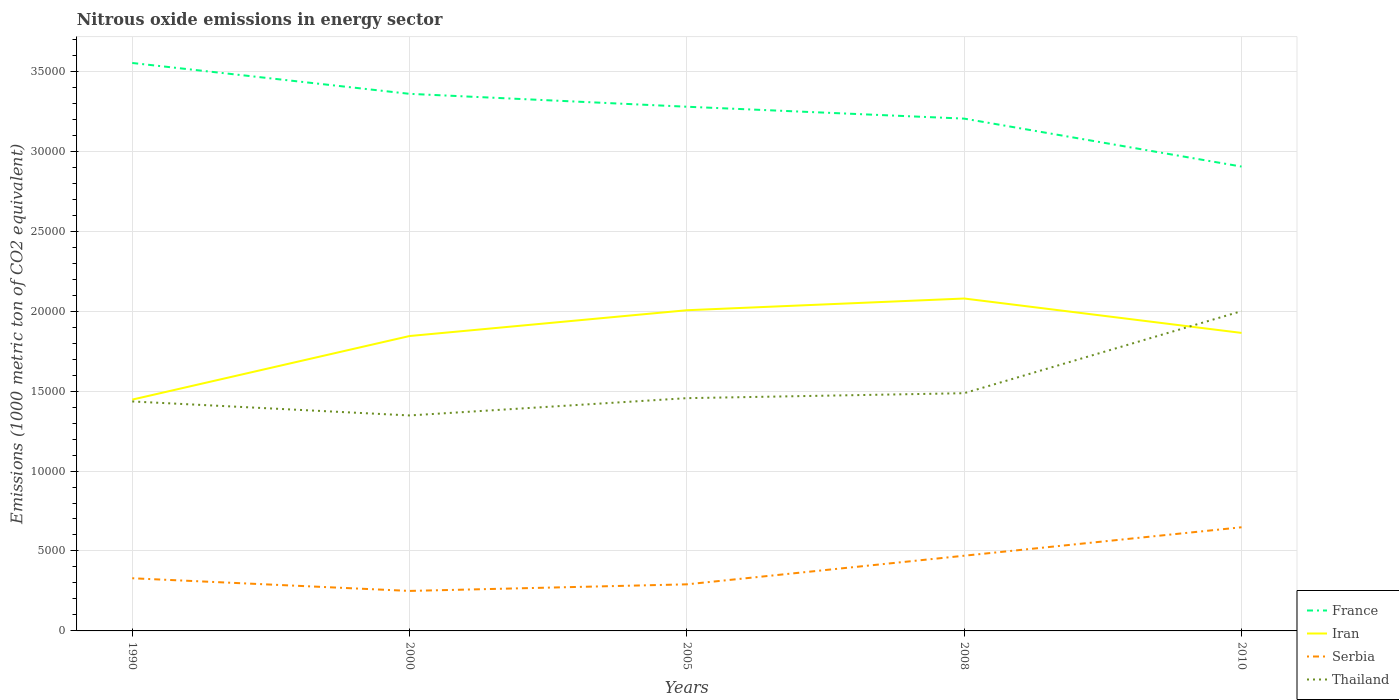Across all years, what is the maximum amount of nitrous oxide emitted in Thailand?
Make the answer very short. 1.35e+04. In which year was the amount of nitrous oxide emitted in Thailand maximum?
Your response must be concise. 2000. What is the total amount of nitrous oxide emitted in Iran in the graph?
Your response must be concise. 2152. What is the difference between the highest and the second highest amount of nitrous oxide emitted in Serbia?
Provide a succinct answer. 3981.3. How many years are there in the graph?
Provide a succinct answer. 5. What is the difference between two consecutive major ticks on the Y-axis?
Keep it short and to the point. 5000. What is the title of the graph?
Provide a short and direct response. Nitrous oxide emissions in energy sector. What is the label or title of the X-axis?
Ensure brevity in your answer.  Years. What is the label or title of the Y-axis?
Provide a succinct answer. Emissions (1000 metric ton of CO2 equivalent). What is the Emissions (1000 metric ton of CO2 equivalent) of France in 1990?
Ensure brevity in your answer.  3.55e+04. What is the Emissions (1000 metric ton of CO2 equivalent) in Iran in 1990?
Keep it short and to the point. 1.45e+04. What is the Emissions (1000 metric ton of CO2 equivalent) of Serbia in 1990?
Make the answer very short. 3293.8. What is the Emissions (1000 metric ton of CO2 equivalent) of Thailand in 1990?
Offer a terse response. 1.44e+04. What is the Emissions (1000 metric ton of CO2 equivalent) of France in 2000?
Offer a terse response. 3.36e+04. What is the Emissions (1000 metric ton of CO2 equivalent) of Iran in 2000?
Your response must be concise. 1.84e+04. What is the Emissions (1000 metric ton of CO2 equivalent) of Serbia in 2000?
Offer a very short reply. 2501.4. What is the Emissions (1000 metric ton of CO2 equivalent) in Thailand in 2000?
Your answer should be compact. 1.35e+04. What is the Emissions (1000 metric ton of CO2 equivalent) in France in 2005?
Keep it short and to the point. 3.28e+04. What is the Emissions (1000 metric ton of CO2 equivalent) of Iran in 2005?
Provide a short and direct response. 2.01e+04. What is the Emissions (1000 metric ton of CO2 equivalent) of Serbia in 2005?
Give a very brief answer. 2913.8. What is the Emissions (1000 metric ton of CO2 equivalent) of Thailand in 2005?
Your answer should be compact. 1.46e+04. What is the Emissions (1000 metric ton of CO2 equivalent) in France in 2008?
Your response must be concise. 3.20e+04. What is the Emissions (1000 metric ton of CO2 equivalent) of Iran in 2008?
Offer a very short reply. 2.08e+04. What is the Emissions (1000 metric ton of CO2 equivalent) of Serbia in 2008?
Your answer should be very brief. 4703.6. What is the Emissions (1000 metric ton of CO2 equivalent) of Thailand in 2008?
Make the answer very short. 1.49e+04. What is the Emissions (1000 metric ton of CO2 equivalent) of France in 2010?
Your answer should be very brief. 2.90e+04. What is the Emissions (1000 metric ton of CO2 equivalent) of Iran in 2010?
Offer a very short reply. 1.86e+04. What is the Emissions (1000 metric ton of CO2 equivalent) in Serbia in 2010?
Provide a succinct answer. 6482.7. What is the Emissions (1000 metric ton of CO2 equivalent) of Thailand in 2010?
Provide a short and direct response. 2.00e+04. Across all years, what is the maximum Emissions (1000 metric ton of CO2 equivalent) of France?
Your answer should be very brief. 3.55e+04. Across all years, what is the maximum Emissions (1000 metric ton of CO2 equivalent) in Iran?
Offer a very short reply. 2.08e+04. Across all years, what is the maximum Emissions (1000 metric ton of CO2 equivalent) of Serbia?
Provide a succinct answer. 6482.7. Across all years, what is the maximum Emissions (1000 metric ton of CO2 equivalent) of Thailand?
Offer a very short reply. 2.00e+04. Across all years, what is the minimum Emissions (1000 metric ton of CO2 equivalent) in France?
Keep it short and to the point. 2.90e+04. Across all years, what is the minimum Emissions (1000 metric ton of CO2 equivalent) of Iran?
Provide a succinct answer. 1.45e+04. Across all years, what is the minimum Emissions (1000 metric ton of CO2 equivalent) of Serbia?
Make the answer very short. 2501.4. Across all years, what is the minimum Emissions (1000 metric ton of CO2 equivalent) in Thailand?
Your response must be concise. 1.35e+04. What is the total Emissions (1000 metric ton of CO2 equivalent) in France in the graph?
Your response must be concise. 1.63e+05. What is the total Emissions (1000 metric ton of CO2 equivalent) of Iran in the graph?
Offer a terse response. 9.24e+04. What is the total Emissions (1000 metric ton of CO2 equivalent) in Serbia in the graph?
Your response must be concise. 1.99e+04. What is the total Emissions (1000 metric ton of CO2 equivalent) in Thailand in the graph?
Keep it short and to the point. 7.73e+04. What is the difference between the Emissions (1000 metric ton of CO2 equivalent) of France in 1990 and that in 2000?
Your answer should be compact. 1930.3. What is the difference between the Emissions (1000 metric ton of CO2 equivalent) in Iran in 1990 and that in 2000?
Offer a terse response. -3977.6. What is the difference between the Emissions (1000 metric ton of CO2 equivalent) in Serbia in 1990 and that in 2000?
Offer a very short reply. 792.4. What is the difference between the Emissions (1000 metric ton of CO2 equivalent) of Thailand in 1990 and that in 2000?
Make the answer very short. 874.7. What is the difference between the Emissions (1000 metric ton of CO2 equivalent) in France in 1990 and that in 2005?
Your answer should be compact. 2736.8. What is the difference between the Emissions (1000 metric ton of CO2 equivalent) of Iran in 1990 and that in 2005?
Provide a short and direct response. -5590.3. What is the difference between the Emissions (1000 metric ton of CO2 equivalent) of Serbia in 1990 and that in 2005?
Provide a succinct answer. 380. What is the difference between the Emissions (1000 metric ton of CO2 equivalent) of Thailand in 1990 and that in 2005?
Provide a short and direct response. -207. What is the difference between the Emissions (1000 metric ton of CO2 equivalent) in France in 1990 and that in 2008?
Provide a short and direct response. 3480.3. What is the difference between the Emissions (1000 metric ton of CO2 equivalent) in Iran in 1990 and that in 2008?
Provide a short and direct response. -6323.6. What is the difference between the Emissions (1000 metric ton of CO2 equivalent) of Serbia in 1990 and that in 2008?
Offer a very short reply. -1409.8. What is the difference between the Emissions (1000 metric ton of CO2 equivalent) in Thailand in 1990 and that in 2008?
Your answer should be compact. -516.3. What is the difference between the Emissions (1000 metric ton of CO2 equivalent) of France in 1990 and that in 2010?
Offer a very short reply. 6479.5. What is the difference between the Emissions (1000 metric ton of CO2 equivalent) of Iran in 1990 and that in 2010?
Your response must be concise. -4171.6. What is the difference between the Emissions (1000 metric ton of CO2 equivalent) of Serbia in 1990 and that in 2010?
Provide a succinct answer. -3188.9. What is the difference between the Emissions (1000 metric ton of CO2 equivalent) in Thailand in 1990 and that in 2010?
Provide a short and direct response. -5648.4. What is the difference between the Emissions (1000 metric ton of CO2 equivalent) in France in 2000 and that in 2005?
Offer a terse response. 806.5. What is the difference between the Emissions (1000 metric ton of CO2 equivalent) in Iran in 2000 and that in 2005?
Ensure brevity in your answer.  -1612.7. What is the difference between the Emissions (1000 metric ton of CO2 equivalent) in Serbia in 2000 and that in 2005?
Your answer should be compact. -412.4. What is the difference between the Emissions (1000 metric ton of CO2 equivalent) of Thailand in 2000 and that in 2005?
Keep it short and to the point. -1081.7. What is the difference between the Emissions (1000 metric ton of CO2 equivalent) of France in 2000 and that in 2008?
Give a very brief answer. 1550. What is the difference between the Emissions (1000 metric ton of CO2 equivalent) in Iran in 2000 and that in 2008?
Give a very brief answer. -2346. What is the difference between the Emissions (1000 metric ton of CO2 equivalent) of Serbia in 2000 and that in 2008?
Keep it short and to the point. -2202.2. What is the difference between the Emissions (1000 metric ton of CO2 equivalent) of Thailand in 2000 and that in 2008?
Your response must be concise. -1391. What is the difference between the Emissions (1000 metric ton of CO2 equivalent) in France in 2000 and that in 2010?
Your answer should be compact. 4549.2. What is the difference between the Emissions (1000 metric ton of CO2 equivalent) in Iran in 2000 and that in 2010?
Keep it short and to the point. -194. What is the difference between the Emissions (1000 metric ton of CO2 equivalent) in Serbia in 2000 and that in 2010?
Provide a short and direct response. -3981.3. What is the difference between the Emissions (1000 metric ton of CO2 equivalent) of Thailand in 2000 and that in 2010?
Offer a very short reply. -6523.1. What is the difference between the Emissions (1000 metric ton of CO2 equivalent) in France in 2005 and that in 2008?
Offer a terse response. 743.5. What is the difference between the Emissions (1000 metric ton of CO2 equivalent) in Iran in 2005 and that in 2008?
Ensure brevity in your answer.  -733.3. What is the difference between the Emissions (1000 metric ton of CO2 equivalent) of Serbia in 2005 and that in 2008?
Give a very brief answer. -1789.8. What is the difference between the Emissions (1000 metric ton of CO2 equivalent) in Thailand in 2005 and that in 2008?
Provide a succinct answer. -309.3. What is the difference between the Emissions (1000 metric ton of CO2 equivalent) of France in 2005 and that in 2010?
Give a very brief answer. 3742.7. What is the difference between the Emissions (1000 metric ton of CO2 equivalent) of Iran in 2005 and that in 2010?
Your answer should be compact. 1418.7. What is the difference between the Emissions (1000 metric ton of CO2 equivalent) in Serbia in 2005 and that in 2010?
Your answer should be very brief. -3568.9. What is the difference between the Emissions (1000 metric ton of CO2 equivalent) in Thailand in 2005 and that in 2010?
Offer a very short reply. -5441.4. What is the difference between the Emissions (1000 metric ton of CO2 equivalent) of France in 2008 and that in 2010?
Make the answer very short. 2999.2. What is the difference between the Emissions (1000 metric ton of CO2 equivalent) in Iran in 2008 and that in 2010?
Offer a very short reply. 2152. What is the difference between the Emissions (1000 metric ton of CO2 equivalent) in Serbia in 2008 and that in 2010?
Give a very brief answer. -1779.1. What is the difference between the Emissions (1000 metric ton of CO2 equivalent) of Thailand in 2008 and that in 2010?
Make the answer very short. -5132.1. What is the difference between the Emissions (1000 metric ton of CO2 equivalent) of France in 1990 and the Emissions (1000 metric ton of CO2 equivalent) of Iran in 2000?
Keep it short and to the point. 1.71e+04. What is the difference between the Emissions (1000 metric ton of CO2 equivalent) of France in 1990 and the Emissions (1000 metric ton of CO2 equivalent) of Serbia in 2000?
Give a very brief answer. 3.30e+04. What is the difference between the Emissions (1000 metric ton of CO2 equivalent) in France in 1990 and the Emissions (1000 metric ton of CO2 equivalent) in Thailand in 2000?
Offer a terse response. 2.20e+04. What is the difference between the Emissions (1000 metric ton of CO2 equivalent) in Iran in 1990 and the Emissions (1000 metric ton of CO2 equivalent) in Serbia in 2000?
Your answer should be compact. 1.20e+04. What is the difference between the Emissions (1000 metric ton of CO2 equivalent) in Iran in 1990 and the Emissions (1000 metric ton of CO2 equivalent) in Thailand in 2000?
Make the answer very short. 989.6. What is the difference between the Emissions (1000 metric ton of CO2 equivalent) in Serbia in 1990 and the Emissions (1000 metric ton of CO2 equivalent) in Thailand in 2000?
Make the answer very short. -1.02e+04. What is the difference between the Emissions (1000 metric ton of CO2 equivalent) of France in 1990 and the Emissions (1000 metric ton of CO2 equivalent) of Iran in 2005?
Ensure brevity in your answer.  1.55e+04. What is the difference between the Emissions (1000 metric ton of CO2 equivalent) of France in 1990 and the Emissions (1000 metric ton of CO2 equivalent) of Serbia in 2005?
Provide a succinct answer. 3.26e+04. What is the difference between the Emissions (1000 metric ton of CO2 equivalent) of France in 1990 and the Emissions (1000 metric ton of CO2 equivalent) of Thailand in 2005?
Your answer should be very brief. 2.10e+04. What is the difference between the Emissions (1000 metric ton of CO2 equivalent) of Iran in 1990 and the Emissions (1000 metric ton of CO2 equivalent) of Serbia in 2005?
Keep it short and to the point. 1.16e+04. What is the difference between the Emissions (1000 metric ton of CO2 equivalent) of Iran in 1990 and the Emissions (1000 metric ton of CO2 equivalent) of Thailand in 2005?
Make the answer very short. -92.1. What is the difference between the Emissions (1000 metric ton of CO2 equivalent) of Serbia in 1990 and the Emissions (1000 metric ton of CO2 equivalent) of Thailand in 2005?
Your answer should be compact. -1.13e+04. What is the difference between the Emissions (1000 metric ton of CO2 equivalent) in France in 1990 and the Emissions (1000 metric ton of CO2 equivalent) in Iran in 2008?
Give a very brief answer. 1.47e+04. What is the difference between the Emissions (1000 metric ton of CO2 equivalent) in France in 1990 and the Emissions (1000 metric ton of CO2 equivalent) in Serbia in 2008?
Ensure brevity in your answer.  3.08e+04. What is the difference between the Emissions (1000 metric ton of CO2 equivalent) in France in 1990 and the Emissions (1000 metric ton of CO2 equivalent) in Thailand in 2008?
Provide a short and direct response. 2.07e+04. What is the difference between the Emissions (1000 metric ton of CO2 equivalent) in Iran in 1990 and the Emissions (1000 metric ton of CO2 equivalent) in Serbia in 2008?
Give a very brief answer. 9762.1. What is the difference between the Emissions (1000 metric ton of CO2 equivalent) of Iran in 1990 and the Emissions (1000 metric ton of CO2 equivalent) of Thailand in 2008?
Make the answer very short. -401.4. What is the difference between the Emissions (1000 metric ton of CO2 equivalent) of Serbia in 1990 and the Emissions (1000 metric ton of CO2 equivalent) of Thailand in 2008?
Keep it short and to the point. -1.16e+04. What is the difference between the Emissions (1000 metric ton of CO2 equivalent) of France in 1990 and the Emissions (1000 metric ton of CO2 equivalent) of Iran in 2010?
Provide a short and direct response. 1.69e+04. What is the difference between the Emissions (1000 metric ton of CO2 equivalent) in France in 1990 and the Emissions (1000 metric ton of CO2 equivalent) in Serbia in 2010?
Offer a very short reply. 2.90e+04. What is the difference between the Emissions (1000 metric ton of CO2 equivalent) in France in 1990 and the Emissions (1000 metric ton of CO2 equivalent) in Thailand in 2010?
Provide a short and direct response. 1.55e+04. What is the difference between the Emissions (1000 metric ton of CO2 equivalent) in Iran in 1990 and the Emissions (1000 metric ton of CO2 equivalent) in Serbia in 2010?
Offer a very short reply. 7983. What is the difference between the Emissions (1000 metric ton of CO2 equivalent) in Iran in 1990 and the Emissions (1000 metric ton of CO2 equivalent) in Thailand in 2010?
Your answer should be compact. -5533.5. What is the difference between the Emissions (1000 metric ton of CO2 equivalent) of Serbia in 1990 and the Emissions (1000 metric ton of CO2 equivalent) of Thailand in 2010?
Offer a very short reply. -1.67e+04. What is the difference between the Emissions (1000 metric ton of CO2 equivalent) in France in 2000 and the Emissions (1000 metric ton of CO2 equivalent) in Iran in 2005?
Ensure brevity in your answer.  1.35e+04. What is the difference between the Emissions (1000 metric ton of CO2 equivalent) in France in 2000 and the Emissions (1000 metric ton of CO2 equivalent) in Serbia in 2005?
Offer a very short reply. 3.07e+04. What is the difference between the Emissions (1000 metric ton of CO2 equivalent) of France in 2000 and the Emissions (1000 metric ton of CO2 equivalent) of Thailand in 2005?
Provide a short and direct response. 1.90e+04. What is the difference between the Emissions (1000 metric ton of CO2 equivalent) of Iran in 2000 and the Emissions (1000 metric ton of CO2 equivalent) of Serbia in 2005?
Your answer should be very brief. 1.55e+04. What is the difference between the Emissions (1000 metric ton of CO2 equivalent) of Iran in 2000 and the Emissions (1000 metric ton of CO2 equivalent) of Thailand in 2005?
Provide a short and direct response. 3885.5. What is the difference between the Emissions (1000 metric ton of CO2 equivalent) in Serbia in 2000 and the Emissions (1000 metric ton of CO2 equivalent) in Thailand in 2005?
Your answer should be very brief. -1.21e+04. What is the difference between the Emissions (1000 metric ton of CO2 equivalent) in France in 2000 and the Emissions (1000 metric ton of CO2 equivalent) in Iran in 2008?
Offer a very short reply. 1.28e+04. What is the difference between the Emissions (1000 metric ton of CO2 equivalent) of France in 2000 and the Emissions (1000 metric ton of CO2 equivalent) of Serbia in 2008?
Offer a very short reply. 2.89e+04. What is the difference between the Emissions (1000 metric ton of CO2 equivalent) in France in 2000 and the Emissions (1000 metric ton of CO2 equivalent) in Thailand in 2008?
Your answer should be very brief. 1.87e+04. What is the difference between the Emissions (1000 metric ton of CO2 equivalent) of Iran in 2000 and the Emissions (1000 metric ton of CO2 equivalent) of Serbia in 2008?
Offer a terse response. 1.37e+04. What is the difference between the Emissions (1000 metric ton of CO2 equivalent) of Iran in 2000 and the Emissions (1000 metric ton of CO2 equivalent) of Thailand in 2008?
Provide a succinct answer. 3576.2. What is the difference between the Emissions (1000 metric ton of CO2 equivalent) of Serbia in 2000 and the Emissions (1000 metric ton of CO2 equivalent) of Thailand in 2008?
Offer a very short reply. -1.24e+04. What is the difference between the Emissions (1000 metric ton of CO2 equivalent) in France in 2000 and the Emissions (1000 metric ton of CO2 equivalent) in Iran in 2010?
Keep it short and to the point. 1.50e+04. What is the difference between the Emissions (1000 metric ton of CO2 equivalent) of France in 2000 and the Emissions (1000 metric ton of CO2 equivalent) of Serbia in 2010?
Offer a very short reply. 2.71e+04. What is the difference between the Emissions (1000 metric ton of CO2 equivalent) of France in 2000 and the Emissions (1000 metric ton of CO2 equivalent) of Thailand in 2010?
Keep it short and to the point. 1.36e+04. What is the difference between the Emissions (1000 metric ton of CO2 equivalent) in Iran in 2000 and the Emissions (1000 metric ton of CO2 equivalent) in Serbia in 2010?
Your response must be concise. 1.20e+04. What is the difference between the Emissions (1000 metric ton of CO2 equivalent) in Iran in 2000 and the Emissions (1000 metric ton of CO2 equivalent) in Thailand in 2010?
Give a very brief answer. -1555.9. What is the difference between the Emissions (1000 metric ton of CO2 equivalent) in Serbia in 2000 and the Emissions (1000 metric ton of CO2 equivalent) in Thailand in 2010?
Give a very brief answer. -1.75e+04. What is the difference between the Emissions (1000 metric ton of CO2 equivalent) in France in 2005 and the Emissions (1000 metric ton of CO2 equivalent) in Iran in 2008?
Your answer should be compact. 1.20e+04. What is the difference between the Emissions (1000 metric ton of CO2 equivalent) of France in 2005 and the Emissions (1000 metric ton of CO2 equivalent) of Serbia in 2008?
Keep it short and to the point. 2.81e+04. What is the difference between the Emissions (1000 metric ton of CO2 equivalent) in France in 2005 and the Emissions (1000 metric ton of CO2 equivalent) in Thailand in 2008?
Make the answer very short. 1.79e+04. What is the difference between the Emissions (1000 metric ton of CO2 equivalent) in Iran in 2005 and the Emissions (1000 metric ton of CO2 equivalent) in Serbia in 2008?
Your answer should be compact. 1.54e+04. What is the difference between the Emissions (1000 metric ton of CO2 equivalent) of Iran in 2005 and the Emissions (1000 metric ton of CO2 equivalent) of Thailand in 2008?
Provide a short and direct response. 5188.9. What is the difference between the Emissions (1000 metric ton of CO2 equivalent) in Serbia in 2005 and the Emissions (1000 metric ton of CO2 equivalent) in Thailand in 2008?
Offer a very short reply. -1.20e+04. What is the difference between the Emissions (1000 metric ton of CO2 equivalent) of France in 2005 and the Emissions (1000 metric ton of CO2 equivalent) of Iran in 2010?
Provide a short and direct response. 1.41e+04. What is the difference between the Emissions (1000 metric ton of CO2 equivalent) of France in 2005 and the Emissions (1000 metric ton of CO2 equivalent) of Serbia in 2010?
Your answer should be very brief. 2.63e+04. What is the difference between the Emissions (1000 metric ton of CO2 equivalent) in France in 2005 and the Emissions (1000 metric ton of CO2 equivalent) in Thailand in 2010?
Offer a very short reply. 1.28e+04. What is the difference between the Emissions (1000 metric ton of CO2 equivalent) of Iran in 2005 and the Emissions (1000 metric ton of CO2 equivalent) of Serbia in 2010?
Offer a terse response. 1.36e+04. What is the difference between the Emissions (1000 metric ton of CO2 equivalent) in Iran in 2005 and the Emissions (1000 metric ton of CO2 equivalent) in Thailand in 2010?
Offer a terse response. 56.8. What is the difference between the Emissions (1000 metric ton of CO2 equivalent) in Serbia in 2005 and the Emissions (1000 metric ton of CO2 equivalent) in Thailand in 2010?
Your answer should be very brief. -1.71e+04. What is the difference between the Emissions (1000 metric ton of CO2 equivalent) in France in 2008 and the Emissions (1000 metric ton of CO2 equivalent) in Iran in 2010?
Keep it short and to the point. 1.34e+04. What is the difference between the Emissions (1000 metric ton of CO2 equivalent) in France in 2008 and the Emissions (1000 metric ton of CO2 equivalent) in Serbia in 2010?
Keep it short and to the point. 2.56e+04. What is the difference between the Emissions (1000 metric ton of CO2 equivalent) in France in 2008 and the Emissions (1000 metric ton of CO2 equivalent) in Thailand in 2010?
Ensure brevity in your answer.  1.20e+04. What is the difference between the Emissions (1000 metric ton of CO2 equivalent) in Iran in 2008 and the Emissions (1000 metric ton of CO2 equivalent) in Serbia in 2010?
Offer a terse response. 1.43e+04. What is the difference between the Emissions (1000 metric ton of CO2 equivalent) in Iran in 2008 and the Emissions (1000 metric ton of CO2 equivalent) in Thailand in 2010?
Make the answer very short. 790.1. What is the difference between the Emissions (1000 metric ton of CO2 equivalent) of Serbia in 2008 and the Emissions (1000 metric ton of CO2 equivalent) of Thailand in 2010?
Your response must be concise. -1.53e+04. What is the average Emissions (1000 metric ton of CO2 equivalent) of France per year?
Provide a succinct answer. 3.26e+04. What is the average Emissions (1000 metric ton of CO2 equivalent) in Iran per year?
Offer a very short reply. 1.85e+04. What is the average Emissions (1000 metric ton of CO2 equivalent) of Serbia per year?
Your answer should be very brief. 3979.06. What is the average Emissions (1000 metric ton of CO2 equivalent) of Thailand per year?
Provide a short and direct response. 1.55e+04. In the year 1990, what is the difference between the Emissions (1000 metric ton of CO2 equivalent) in France and Emissions (1000 metric ton of CO2 equivalent) in Iran?
Provide a succinct answer. 2.11e+04. In the year 1990, what is the difference between the Emissions (1000 metric ton of CO2 equivalent) of France and Emissions (1000 metric ton of CO2 equivalent) of Serbia?
Give a very brief answer. 3.22e+04. In the year 1990, what is the difference between the Emissions (1000 metric ton of CO2 equivalent) of France and Emissions (1000 metric ton of CO2 equivalent) of Thailand?
Offer a very short reply. 2.12e+04. In the year 1990, what is the difference between the Emissions (1000 metric ton of CO2 equivalent) in Iran and Emissions (1000 metric ton of CO2 equivalent) in Serbia?
Provide a short and direct response. 1.12e+04. In the year 1990, what is the difference between the Emissions (1000 metric ton of CO2 equivalent) in Iran and Emissions (1000 metric ton of CO2 equivalent) in Thailand?
Offer a terse response. 114.9. In the year 1990, what is the difference between the Emissions (1000 metric ton of CO2 equivalent) in Serbia and Emissions (1000 metric ton of CO2 equivalent) in Thailand?
Provide a succinct answer. -1.11e+04. In the year 2000, what is the difference between the Emissions (1000 metric ton of CO2 equivalent) in France and Emissions (1000 metric ton of CO2 equivalent) in Iran?
Your response must be concise. 1.51e+04. In the year 2000, what is the difference between the Emissions (1000 metric ton of CO2 equivalent) in France and Emissions (1000 metric ton of CO2 equivalent) in Serbia?
Ensure brevity in your answer.  3.11e+04. In the year 2000, what is the difference between the Emissions (1000 metric ton of CO2 equivalent) in France and Emissions (1000 metric ton of CO2 equivalent) in Thailand?
Your response must be concise. 2.01e+04. In the year 2000, what is the difference between the Emissions (1000 metric ton of CO2 equivalent) of Iran and Emissions (1000 metric ton of CO2 equivalent) of Serbia?
Offer a very short reply. 1.59e+04. In the year 2000, what is the difference between the Emissions (1000 metric ton of CO2 equivalent) of Iran and Emissions (1000 metric ton of CO2 equivalent) of Thailand?
Offer a terse response. 4967.2. In the year 2000, what is the difference between the Emissions (1000 metric ton of CO2 equivalent) of Serbia and Emissions (1000 metric ton of CO2 equivalent) of Thailand?
Your answer should be compact. -1.10e+04. In the year 2005, what is the difference between the Emissions (1000 metric ton of CO2 equivalent) of France and Emissions (1000 metric ton of CO2 equivalent) of Iran?
Offer a terse response. 1.27e+04. In the year 2005, what is the difference between the Emissions (1000 metric ton of CO2 equivalent) in France and Emissions (1000 metric ton of CO2 equivalent) in Serbia?
Your answer should be very brief. 2.99e+04. In the year 2005, what is the difference between the Emissions (1000 metric ton of CO2 equivalent) in France and Emissions (1000 metric ton of CO2 equivalent) in Thailand?
Offer a very short reply. 1.82e+04. In the year 2005, what is the difference between the Emissions (1000 metric ton of CO2 equivalent) in Iran and Emissions (1000 metric ton of CO2 equivalent) in Serbia?
Ensure brevity in your answer.  1.71e+04. In the year 2005, what is the difference between the Emissions (1000 metric ton of CO2 equivalent) in Iran and Emissions (1000 metric ton of CO2 equivalent) in Thailand?
Your answer should be very brief. 5498.2. In the year 2005, what is the difference between the Emissions (1000 metric ton of CO2 equivalent) in Serbia and Emissions (1000 metric ton of CO2 equivalent) in Thailand?
Offer a very short reply. -1.16e+04. In the year 2008, what is the difference between the Emissions (1000 metric ton of CO2 equivalent) in France and Emissions (1000 metric ton of CO2 equivalent) in Iran?
Make the answer very short. 1.13e+04. In the year 2008, what is the difference between the Emissions (1000 metric ton of CO2 equivalent) in France and Emissions (1000 metric ton of CO2 equivalent) in Serbia?
Keep it short and to the point. 2.73e+04. In the year 2008, what is the difference between the Emissions (1000 metric ton of CO2 equivalent) of France and Emissions (1000 metric ton of CO2 equivalent) of Thailand?
Your answer should be compact. 1.72e+04. In the year 2008, what is the difference between the Emissions (1000 metric ton of CO2 equivalent) of Iran and Emissions (1000 metric ton of CO2 equivalent) of Serbia?
Offer a very short reply. 1.61e+04. In the year 2008, what is the difference between the Emissions (1000 metric ton of CO2 equivalent) in Iran and Emissions (1000 metric ton of CO2 equivalent) in Thailand?
Ensure brevity in your answer.  5922.2. In the year 2008, what is the difference between the Emissions (1000 metric ton of CO2 equivalent) of Serbia and Emissions (1000 metric ton of CO2 equivalent) of Thailand?
Give a very brief answer. -1.02e+04. In the year 2010, what is the difference between the Emissions (1000 metric ton of CO2 equivalent) in France and Emissions (1000 metric ton of CO2 equivalent) in Iran?
Make the answer very short. 1.04e+04. In the year 2010, what is the difference between the Emissions (1000 metric ton of CO2 equivalent) in France and Emissions (1000 metric ton of CO2 equivalent) in Serbia?
Ensure brevity in your answer.  2.26e+04. In the year 2010, what is the difference between the Emissions (1000 metric ton of CO2 equivalent) in France and Emissions (1000 metric ton of CO2 equivalent) in Thailand?
Keep it short and to the point. 9041.2. In the year 2010, what is the difference between the Emissions (1000 metric ton of CO2 equivalent) in Iran and Emissions (1000 metric ton of CO2 equivalent) in Serbia?
Your answer should be very brief. 1.22e+04. In the year 2010, what is the difference between the Emissions (1000 metric ton of CO2 equivalent) in Iran and Emissions (1000 metric ton of CO2 equivalent) in Thailand?
Provide a succinct answer. -1361.9. In the year 2010, what is the difference between the Emissions (1000 metric ton of CO2 equivalent) in Serbia and Emissions (1000 metric ton of CO2 equivalent) in Thailand?
Offer a terse response. -1.35e+04. What is the ratio of the Emissions (1000 metric ton of CO2 equivalent) in France in 1990 to that in 2000?
Keep it short and to the point. 1.06. What is the ratio of the Emissions (1000 metric ton of CO2 equivalent) of Iran in 1990 to that in 2000?
Your response must be concise. 0.78. What is the ratio of the Emissions (1000 metric ton of CO2 equivalent) of Serbia in 1990 to that in 2000?
Keep it short and to the point. 1.32. What is the ratio of the Emissions (1000 metric ton of CO2 equivalent) in Thailand in 1990 to that in 2000?
Your answer should be compact. 1.06. What is the ratio of the Emissions (1000 metric ton of CO2 equivalent) of France in 1990 to that in 2005?
Your answer should be very brief. 1.08. What is the ratio of the Emissions (1000 metric ton of CO2 equivalent) in Iran in 1990 to that in 2005?
Offer a very short reply. 0.72. What is the ratio of the Emissions (1000 metric ton of CO2 equivalent) of Serbia in 1990 to that in 2005?
Your answer should be compact. 1.13. What is the ratio of the Emissions (1000 metric ton of CO2 equivalent) of Thailand in 1990 to that in 2005?
Your response must be concise. 0.99. What is the ratio of the Emissions (1000 metric ton of CO2 equivalent) in France in 1990 to that in 2008?
Your answer should be very brief. 1.11. What is the ratio of the Emissions (1000 metric ton of CO2 equivalent) in Iran in 1990 to that in 2008?
Offer a very short reply. 0.7. What is the ratio of the Emissions (1000 metric ton of CO2 equivalent) of Serbia in 1990 to that in 2008?
Make the answer very short. 0.7. What is the ratio of the Emissions (1000 metric ton of CO2 equivalent) in Thailand in 1990 to that in 2008?
Make the answer very short. 0.97. What is the ratio of the Emissions (1000 metric ton of CO2 equivalent) in France in 1990 to that in 2010?
Offer a very short reply. 1.22. What is the ratio of the Emissions (1000 metric ton of CO2 equivalent) of Iran in 1990 to that in 2010?
Give a very brief answer. 0.78. What is the ratio of the Emissions (1000 metric ton of CO2 equivalent) of Serbia in 1990 to that in 2010?
Provide a succinct answer. 0.51. What is the ratio of the Emissions (1000 metric ton of CO2 equivalent) of Thailand in 1990 to that in 2010?
Keep it short and to the point. 0.72. What is the ratio of the Emissions (1000 metric ton of CO2 equivalent) of France in 2000 to that in 2005?
Offer a terse response. 1.02. What is the ratio of the Emissions (1000 metric ton of CO2 equivalent) of Iran in 2000 to that in 2005?
Your answer should be very brief. 0.92. What is the ratio of the Emissions (1000 metric ton of CO2 equivalent) of Serbia in 2000 to that in 2005?
Offer a very short reply. 0.86. What is the ratio of the Emissions (1000 metric ton of CO2 equivalent) in Thailand in 2000 to that in 2005?
Your response must be concise. 0.93. What is the ratio of the Emissions (1000 metric ton of CO2 equivalent) in France in 2000 to that in 2008?
Keep it short and to the point. 1.05. What is the ratio of the Emissions (1000 metric ton of CO2 equivalent) of Iran in 2000 to that in 2008?
Your answer should be very brief. 0.89. What is the ratio of the Emissions (1000 metric ton of CO2 equivalent) in Serbia in 2000 to that in 2008?
Your answer should be compact. 0.53. What is the ratio of the Emissions (1000 metric ton of CO2 equivalent) of Thailand in 2000 to that in 2008?
Ensure brevity in your answer.  0.91. What is the ratio of the Emissions (1000 metric ton of CO2 equivalent) in France in 2000 to that in 2010?
Offer a very short reply. 1.16. What is the ratio of the Emissions (1000 metric ton of CO2 equivalent) of Serbia in 2000 to that in 2010?
Provide a short and direct response. 0.39. What is the ratio of the Emissions (1000 metric ton of CO2 equivalent) in Thailand in 2000 to that in 2010?
Your answer should be very brief. 0.67. What is the ratio of the Emissions (1000 metric ton of CO2 equivalent) of France in 2005 to that in 2008?
Provide a short and direct response. 1.02. What is the ratio of the Emissions (1000 metric ton of CO2 equivalent) of Iran in 2005 to that in 2008?
Your answer should be very brief. 0.96. What is the ratio of the Emissions (1000 metric ton of CO2 equivalent) in Serbia in 2005 to that in 2008?
Your answer should be compact. 0.62. What is the ratio of the Emissions (1000 metric ton of CO2 equivalent) in Thailand in 2005 to that in 2008?
Your answer should be very brief. 0.98. What is the ratio of the Emissions (1000 metric ton of CO2 equivalent) in France in 2005 to that in 2010?
Make the answer very short. 1.13. What is the ratio of the Emissions (1000 metric ton of CO2 equivalent) in Iran in 2005 to that in 2010?
Make the answer very short. 1.08. What is the ratio of the Emissions (1000 metric ton of CO2 equivalent) of Serbia in 2005 to that in 2010?
Your response must be concise. 0.45. What is the ratio of the Emissions (1000 metric ton of CO2 equivalent) in Thailand in 2005 to that in 2010?
Offer a very short reply. 0.73. What is the ratio of the Emissions (1000 metric ton of CO2 equivalent) in France in 2008 to that in 2010?
Your response must be concise. 1.1. What is the ratio of the Emissions (1000 metric ton of CO2 equivalent) in Iran in 2008 to that in 2010?
Give a very brief answer. 1.12. What is the ratio of the Emissions (1000 metric ton of CO2 equivalent) in Serbia in 2008 to that in 2010?
Provide a short and direct response. 0.73. What is the ratio of the Emissions (1000 metric ton of CO2 equivalent) of Thailand in 2008 to that in 2010?
Make the answer very short. 0.74. What is the difference between the highest and the second highest Emissions (1000 metric ton of CO2 equivalent) in France?
Offer a terse response. 1930.3. What is the difference between the highest and the second highest Emissions (1000 metric ton of CO2 equivalent) in Iran?
Keep it short and to the point. 733.3. What is the difference between the highest and the second highest Emissions (1000 metric ton of CO2 equivalent) in Serbia?
Offer a terse response. 1779.1. What is the difference between the highest and the second highest Emissions (1000 metric ton of CO2 equivalent) in Thailand?
Ensure brevity in your answer.  5132.1. What is the difference between the highest and the lowest Emissions (1000 metric ton of CO2 equivalent) of France?
Make the answer very short. 6479.5. What is the difference between the highest and the lowest Emissions (1000 metric ton of CO2 equivalent) in Iran?
Give a very brief answer. 6323.6. What is the difference between the highest and the lowest Emissions (1000 metric ton of CO2 equivalent) of Serbia?
Keep it short and to the point. 3981.3. What is the difference between the highest and the lowest Emissions (1000 metric ton of CO2 equivalent) of Thailand?
Provide a short and direct response. 6523.1. 